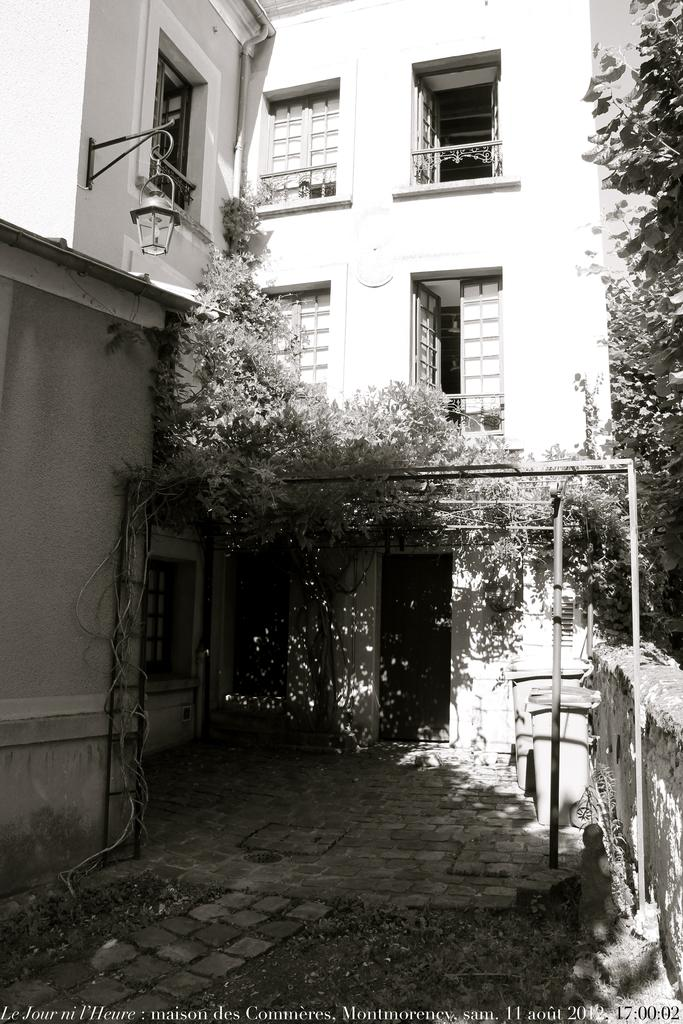What type of structure is visible in the image? There is a building in the image. What is the state of the doors on the building? The doors of the houses are open. What natural element is present in front of the building? There is a tree in front of the building. Can you describe the lighting fixture on the building? A light is hanged on the left side of the wall. What type of grain is being harvested in the image? There is no grain or harvesting activity present in the image. How many carriages are parked in front of the building? There are no carriages visible in the image. 